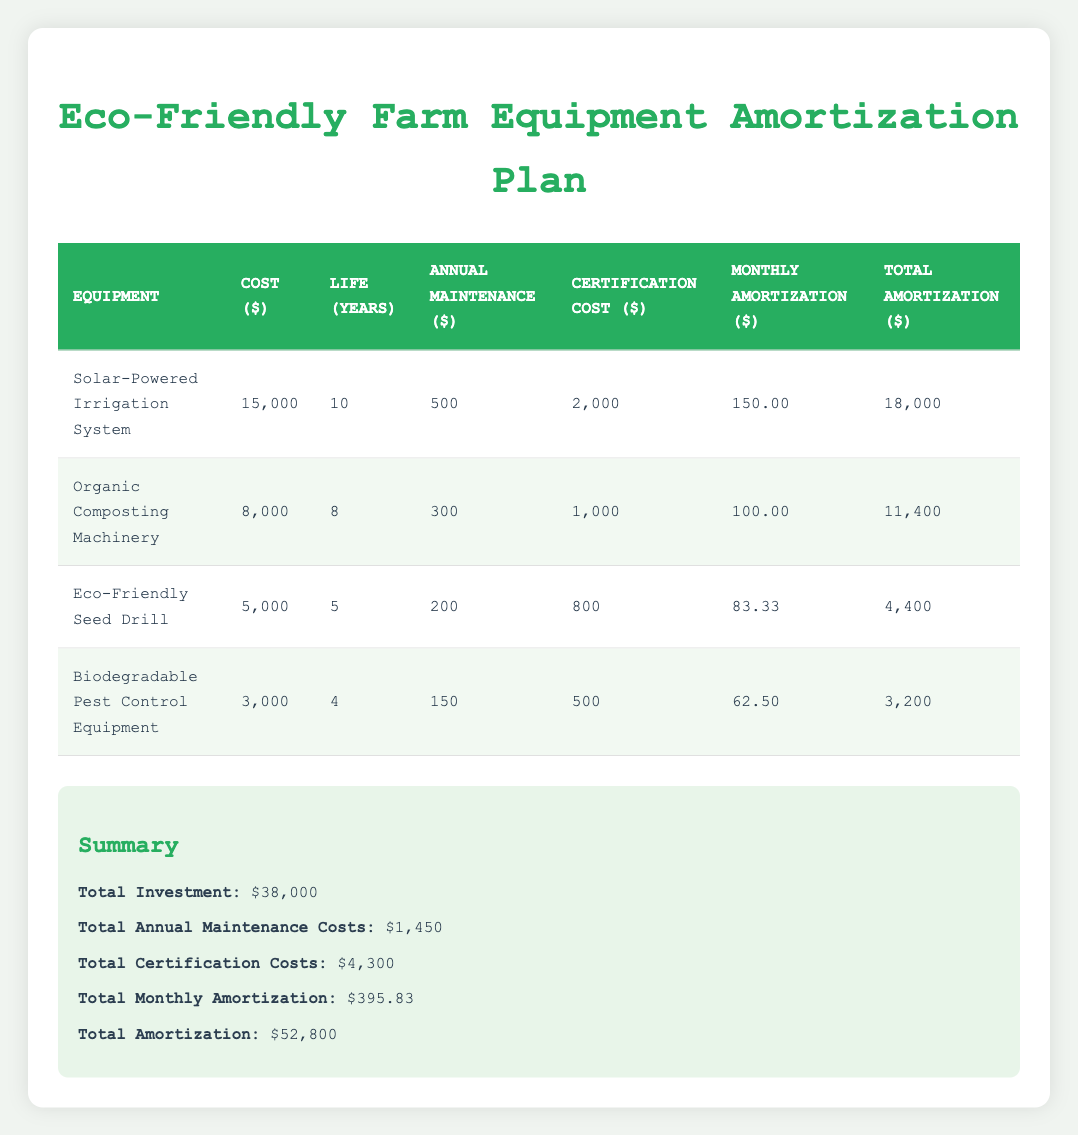What is the total cost of the Solar-Powered Irrigation System? The table shows that the cost value for the Solar-Powered Irrigation System is $15,000.
Answer: 15000 How much is the annual maintenance cost for the Biodegradable Pest Control Equipment? Referring to the table, the annual maintenance cost for the Biodegradable Pest Control Equipment is $150.
Answer: 150 What is the combined total amortization of both the Organic Composting Machinery and the Eco-Friendly Seed Drill? The total amortization for the Organic Composting Machinery is $11,400 and for the Eco-Friendly Seed Drill is $4,400. Therefore, we add these two values: 11,400 + 4,400 = 15,800.
Answer: 15800 Is the total monthly amortization greater than the monthly amortization of the Solar-Powered Irrigation System? The total monthly amortization is $395.83, and the monthly amortization for the Solar-Powered Irrigation System is $150. Since $395.83 is greater than $150, the answer is yes.
Answer: Yes What is the average annual maintenance cost of all equipment listed in the table? We sum the annual maintenance costs: 500 (Solar-Powered Irrigation) + 300 (Organic Composting) + 200 (Eco-Friendly Seed Drill) + 150 (Biodegradable Pest Control) = 1150. Then, divide this total by the number of equipment items, which is 4: 1150 / 4 = 287.5.
Answer: 287.5 How much more is the certification cost for the Solar-Powered Irrigation System compared to the Biodegradable Pest Control Equipment? The certification cost for the Solar-Powered Irrigation System is $2,000, and for the Biodegradable Pest Control Equipment, it is $500. Subtracting these gives us 2,000 - 500 = 1,500.
Answer: 1500 Is the Eco-Friendly Seed Drill more expensive than the Biodegradable Pest Control Equipment? The Eco-Friendly Seed Drill costs $5,000, while the Biodegradable Pest Control Equipment costs $3,000. Since $5,000 is greater than $3,000, the answer is yes.
Answer: Yes What is the total investment cost for all the equipment? The total investment shown in the summary section of the table is $38,000.
Answer: 38000 What is the total amortization amount for all the equipment combined? The total amortization listed in the summary section is $52,800, which combines all individual total amortization values.
Answer: 52800 